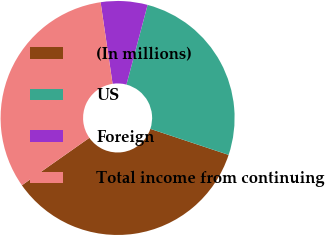<chart> <loc_0><loc_0><loc_500><loc_500><pie_chart><fcel>(In millions)<fcel>US<fcel>Foreign<fcel>Total income from continuing<nl><fcel>35.14%<fcel>25.98%<fcel>6.45%<fcel>32.43%<nl></chart> 